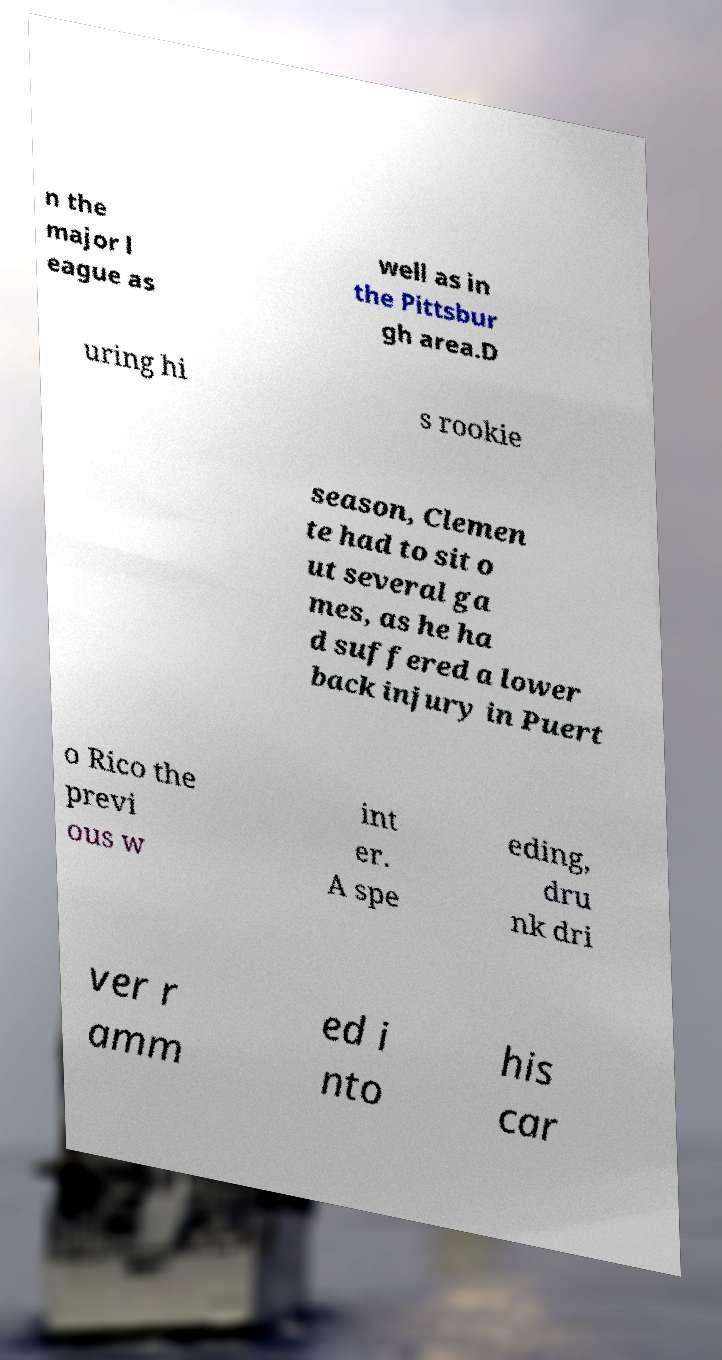Please read and relay the text visible in this image. What does it say? n the major l eague as well as in the Pittsbur gh area.D uring hi s rookie season, Clemen te had to sit o ut several ga mes, as he ha d suffered a lower back injury in Puert o Rico the previ ous w int er. A spe eding, dru nk dri ver r amm ed i nto his car 